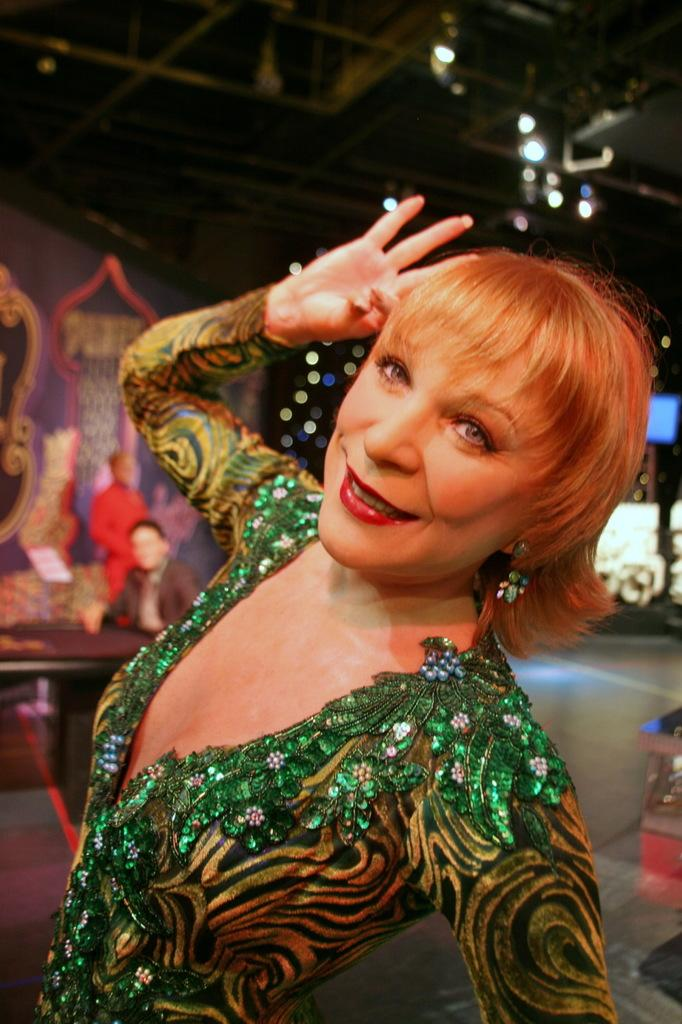Who is the main subject in the image? There is a lady in the center of the image. What is the lady doing in the image? The lady is smiling. What is the lady wearing in the image? The lady is wearing a green dress. What can be seen in the background of the image? There are people and a wall in the background of the image. What is visible at the top of the image? There are lights visible at the top of the image. Are there any fairies visible in the image? No, there are no fairies present in the image. What type of weather condition is depicted by the sleet in the image? There is no mention of sleet in the image; it does not depict any weather conditions. 